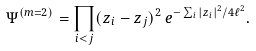Convert formula to latex. <formula><loc_0><loc_0><loc_500><loc_500>\Psi ^ { ( m = 2 ) } = \prod _ { i < j } ( z _ { i } - z _ { j } ) ^ { 2 } \, e ^ { - \sum _ { i } | z _ { i } | ^ { 2 } / 4 \ell ^ { 2 } } .</formula> 